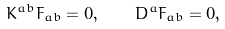Convert formula to latex. <formula><loc_0><loc_0><loc_500><loc_500>K ^ { a b } F _ { a b } = 0 , \quad D ^ { a } F _ { a b } = 0 ,</formula> 